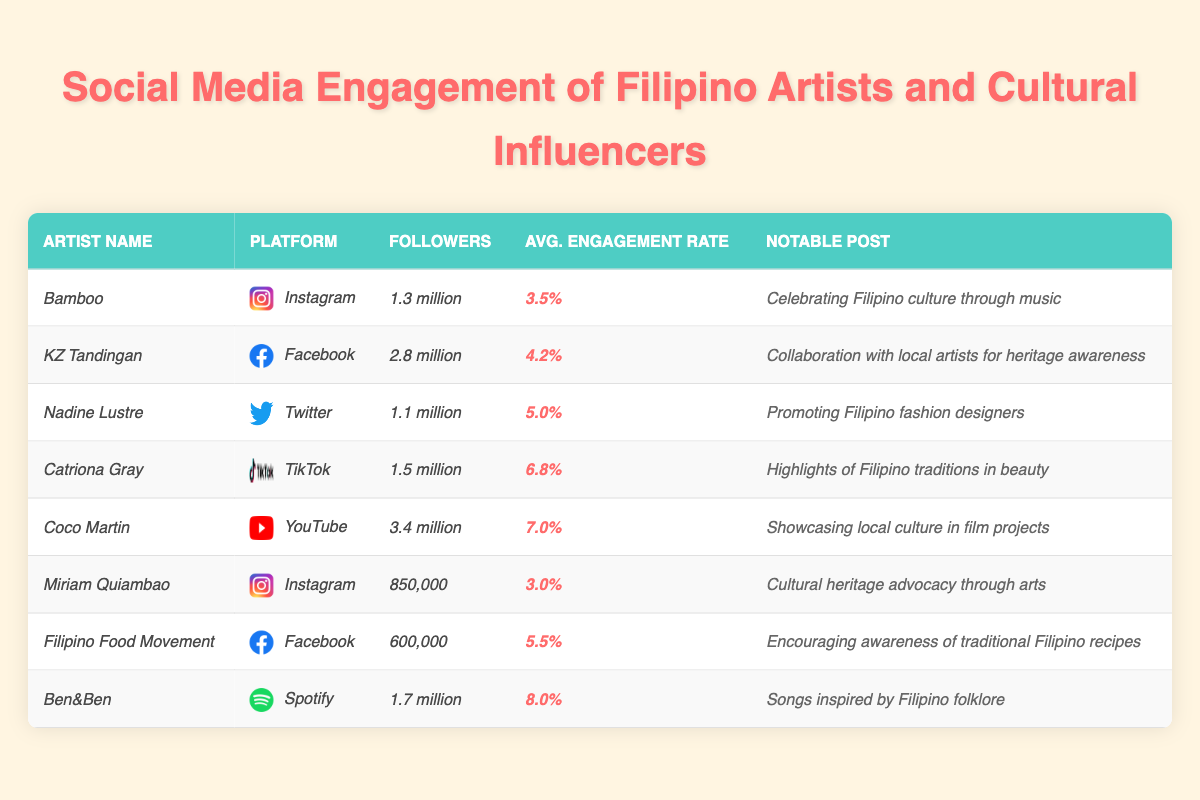What is the average engagement rate of the artists listed? Add all the average engagement rates: (3.5% + 4.2% + 5.0% + 6.8% + 7.0% + 3.0% + 5.5% + 8.0%) = 43.0%. There are 8 artists, so divide the total by 8: 43.0% / 8 = 5.375%
Answer: 5.38% Who has the highest number of followers and on which platform? Looking at the "Followers" column, Coco Martin has 3.4 million followers, which is the highest. He is on YouTube
Answer: Coco Martin, YouTube Which artist has the most notable engagement rate and what is it? Ben&Ben has the highest engagement rate at 8.0%. This is identified by comparing the engagement rates in the respective column
Answer: Ben&Ben, 8.0% Is KZ Tandingan more popular on Instagram or Facebook? KZ Tandingan is on Facebook with 2.8 million followers, while no Instagram user in the table surpasses this follower count. Therefore, she is more popular on Facebook
Answer: Facebook How many more followers does Coco Martin have compared to Miriam Quiambao? Coco Martin has 3.4 million followers and Miriam Quiambao has 850,000. The difference is 3.4 million - 850,000 = 2.55 million
Answer: 2.55 million What engagement rate does Catriona Gray have and how does it compare to the average engagement rate listed? Catriona Gray has an engagement rate of 6.8%. The average engagement rate is 5.375%, and 6.8% is higher than the average
Answer: 6.8%, higher than average Are there any artists featured on Instagram, and what is the range of their engagement rates? The artists on Instagram are Bamboo and Miriam Quiambao, with engagement rates of 3.5% and 3.0% respectively. The range is 3.5% - 3.0% = 0.5%
Answer: 0.5% If we only consider artists with over 1 million followers, what is the average engagement rate of that group? The artists with over 1 million followers are Bamboo, KZ Tandingan, Catriona Gray, Coco Martin, and Ben&Ben. Their engagement rates are 3.5%, 4.2%, 6.8%, 7.0%, and 8.0%. The sum is (3.5 + 4.2 + 6.8 + 7.0 + 8.0) = 29.5%. There are 5 artists, so divide by 5: 29.5% / 5 = 5.9%
Answer: 5.9% Which platform has the lowest engagement rate among artists listed? By comparing all engagement rates, Miriam Quiambao on Instagram has the lowest at 3.0%
Answer: Instagram, 3.0% 